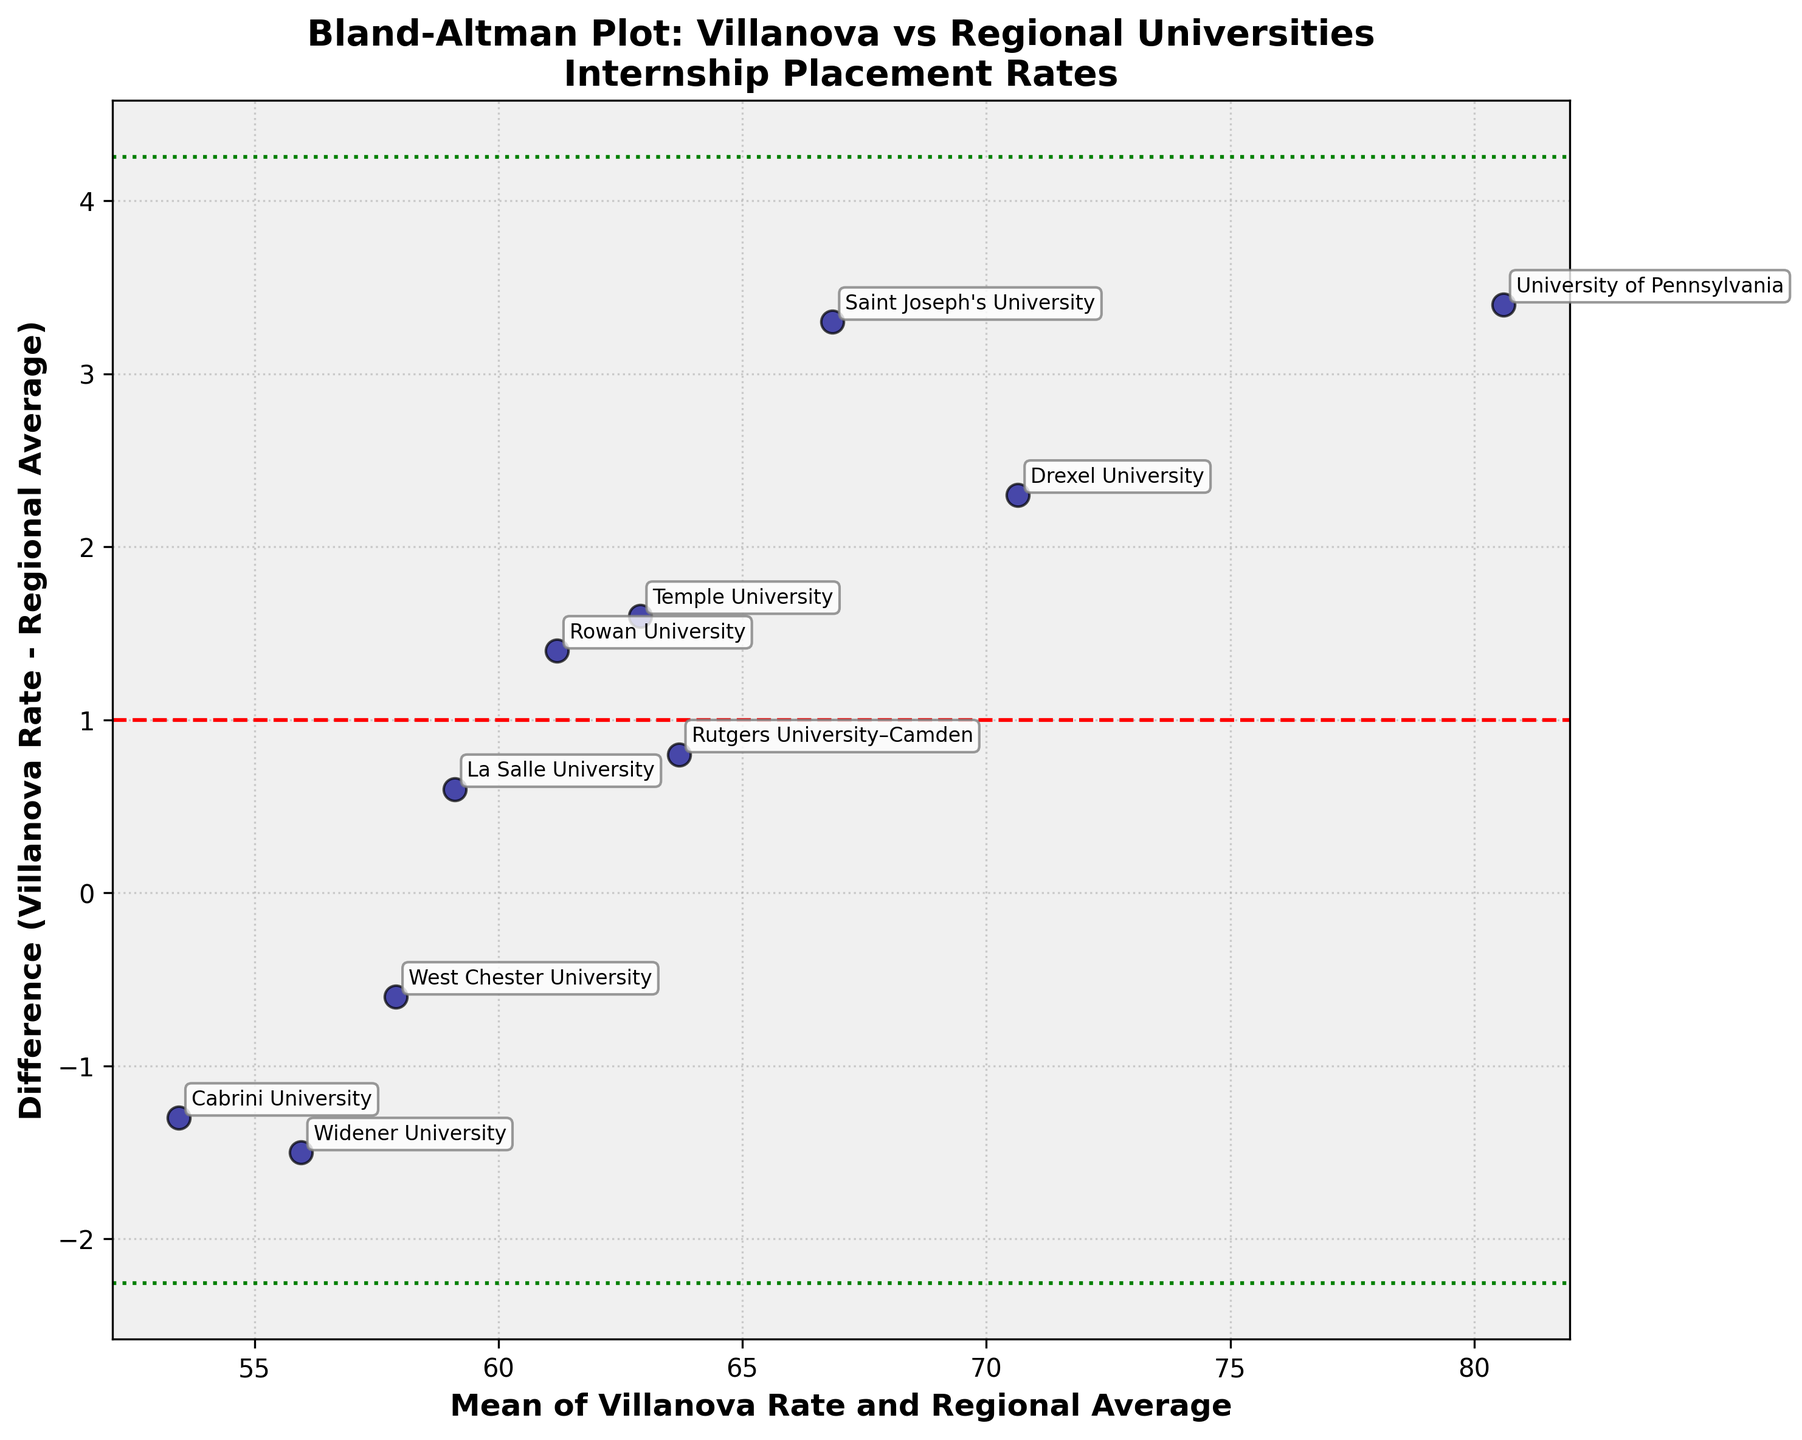How many universities are plotted in the figure? Count the number of data points or annotated labels visible on the Bland-Altman plot.
Answer: 10 What is the purpose of the red dashed line on the plot? The red dashed line represents the mean difference between the Villanova internship placement rates and the regional averages. It's used to assess the average bias in the data.
Answer: Mean difference Which university has the highest difference value? Identify the highest data point on the y-axis (difference) and refer to its label.
Answer: University of Pennsylvania How many universities have a negative difference in internship placement rates? Count the number of data points that are below the zero line on the y-axis (negative differences).
Answer: 3 What is the range of values shown on the x-axis? Identify the minimum and maximum values of the mean of Villanova Rate and Regional Average on the x-axis.
Answer: Approximately 48 to 80 Which university is closest to the mean difference line? Identify the data point that is nearest to the red dashed line.
Answer: La Salle University How many universities have a difference greater than 2.0? Count the data points that are above the y-axis value of 2.0.
Answer: 3 Which universities fall beyond the green dotted lines? Identify the data points that are beyond +/- 1.96 times the standard deviation of the differences, represented by the green dotted lines.
Answer: None What is the average of differences in internship placement rates? The red dashed line on the y-axis represents the mean difference, and it's depicted in the plot. Locate the value at this line.
Answer: 0.98 What are the values of the green dotted lines on the plot? The green dotted lines represent the limits of agreement, which are mean +/- 1.96 times the standard deviation of the differences. These values can be read from the intersection points of the green dotted lines with the y-axis.
Answer: Approximately 0.98 ± 1.96 * 1.44 (precise calculation needed for exact values) 